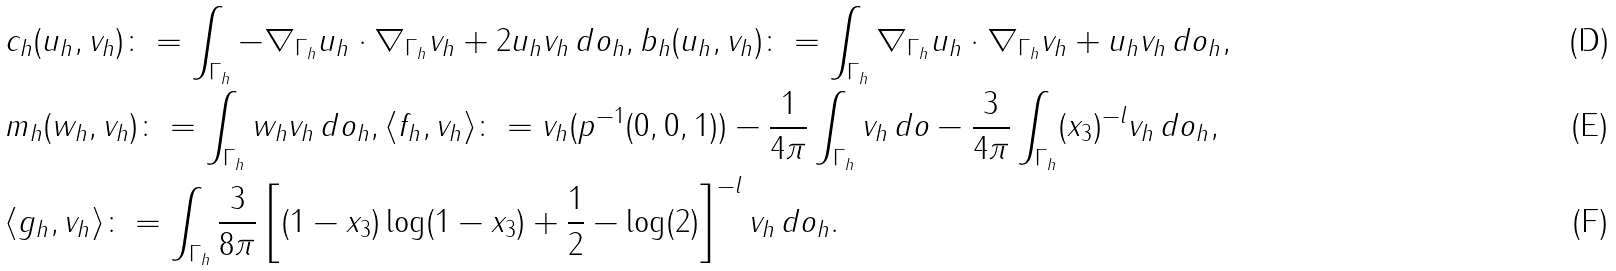Convert formula to latex. <formula><loc_0><loc_0><loc_500><loc_500>& c _ { h } ( u _ { h } , v _ { h } ) \colon = \int _ { \Gamma _ { h } } - \nabla _ { \Gamma _ { h } } u _ { h } \cdot \nabla _ { \Gamma _ { h } } v _ { h } + 2 u _ { h } v _ { h } \, d o _ { h } , b _ { h } ( u _ { h } , v _ { h } ) \colon = \int _ { \Gamma _ { h } } \nabla _ { \Gamma _ { h } } u _ { h } \cdot \nabla _ { \Gamma _ { h } } v _ { h } + u _ { h } v _ { h } \, d o _ { h } , \\ & m _ { h } ( w _ { h } , v _ { h } ) \colon = \int _ { \Gamma _ { h } } w _ { h } v _ { h } \, d o _ { h } , \langle f _ { h } , v _ { h } \rangle \colon = v _ { h } ( p ^ { - 1 } ( 0 , 0 , 1 ) ) - \frac { 1 } { 4 \pi } \int _ { \Gamma _ { h } } v _ { h } \, d o - \frac { 3 } { 4 \pi } \int _ { \Gamma _ { h } } ( x _ { 3 } ) ^ { - l } v _ { h } \, d o _ { h } , \\ & \langle g _ { h } , v _ { h } \rangle \colon = \int _ { \Gamma _ { h } } \frac { 3 } { 8 \pi } \left [ ( 1 - x _ { 3 } ) \log ( 1 - x _ { 3 } ) + \frac { 1 } { 2 } - \log ( 2 ) \right ] ^ { - l } v _ { h } \, d o _ { h } .</formula> 